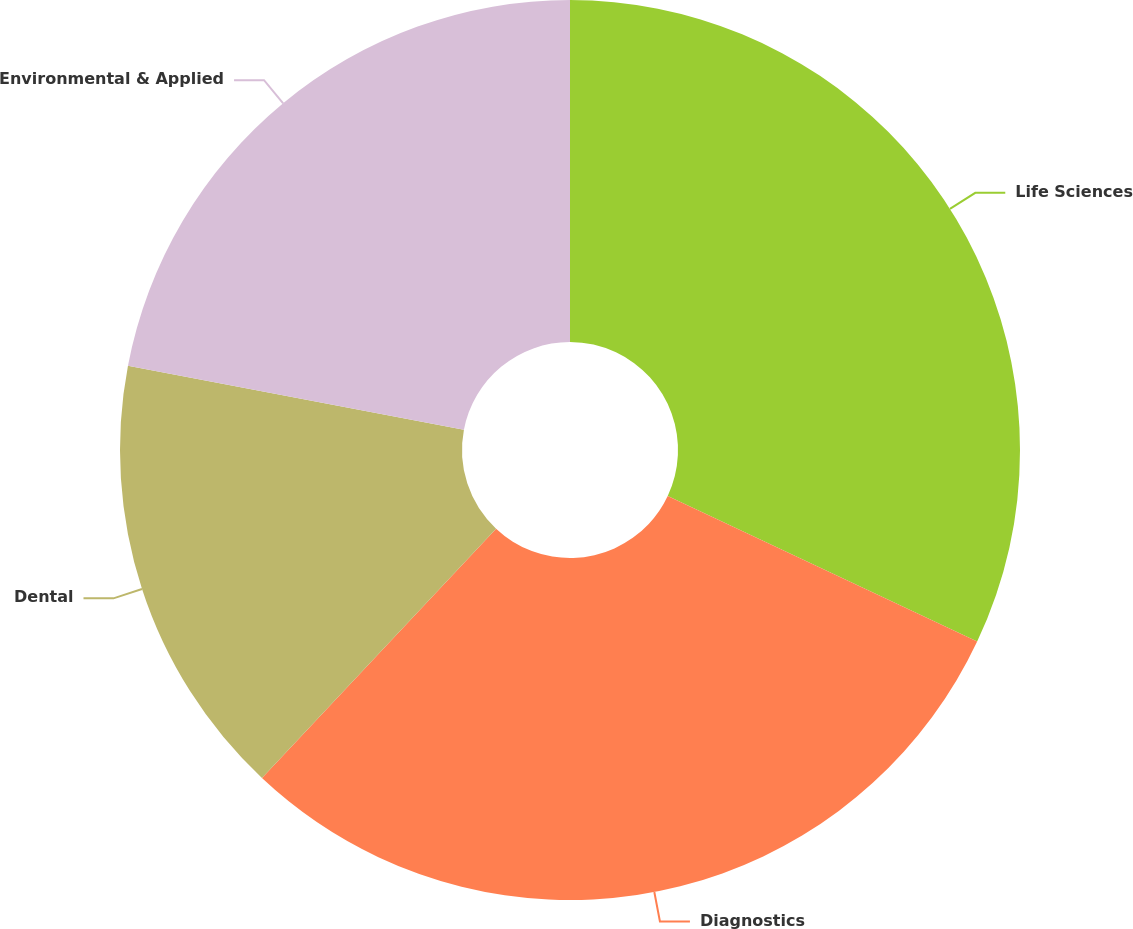<chart> <loc_0><loc_0><loc_500><loc_500><pie_chart><fcel>Life Sciences<fcel>Diagnostics<fcel>Dental<fcel>Environmental & Applied<nl><fcel>32.0%<fcel>30.0%<fcel>16.0%<fcel>22.0%<nl></chart> 